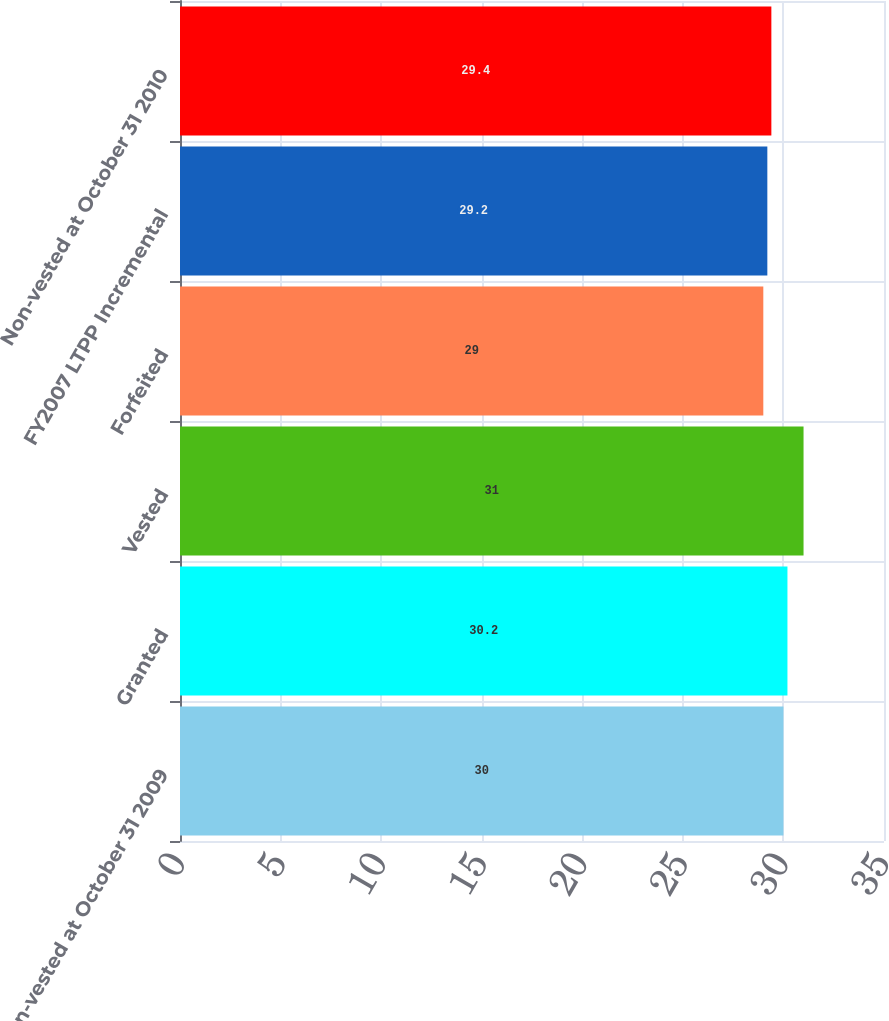Convert chart. <chart><loc_0><loc_0><loc_500><loc_500><bar_chart><fcel>Non-vested at October 31 2009<fcel>Granted<fcel>Vested<fcel>Forfeited<fcel>FY2007 LTPP Incremental<fcel>Non-vested at October 31 2010<nl><fcel>30<fcel>30.2<fcel>31<fcel>29<fcel>29.2<fcel>29.4<nl></chart> 